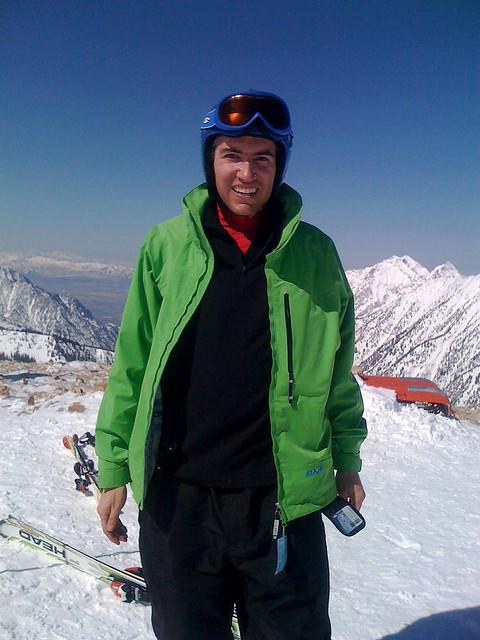Can you see the man's face?
Give a very brief answer. Yes. Is that a phone in his hand?
Give a very brief answer. Yes. Will he be going downhill soon?
Quick response, please. Yes. What is the man wearing on his head?
Keep it brief. Goggles. What color is his coat?
Answer briefly. Green. 